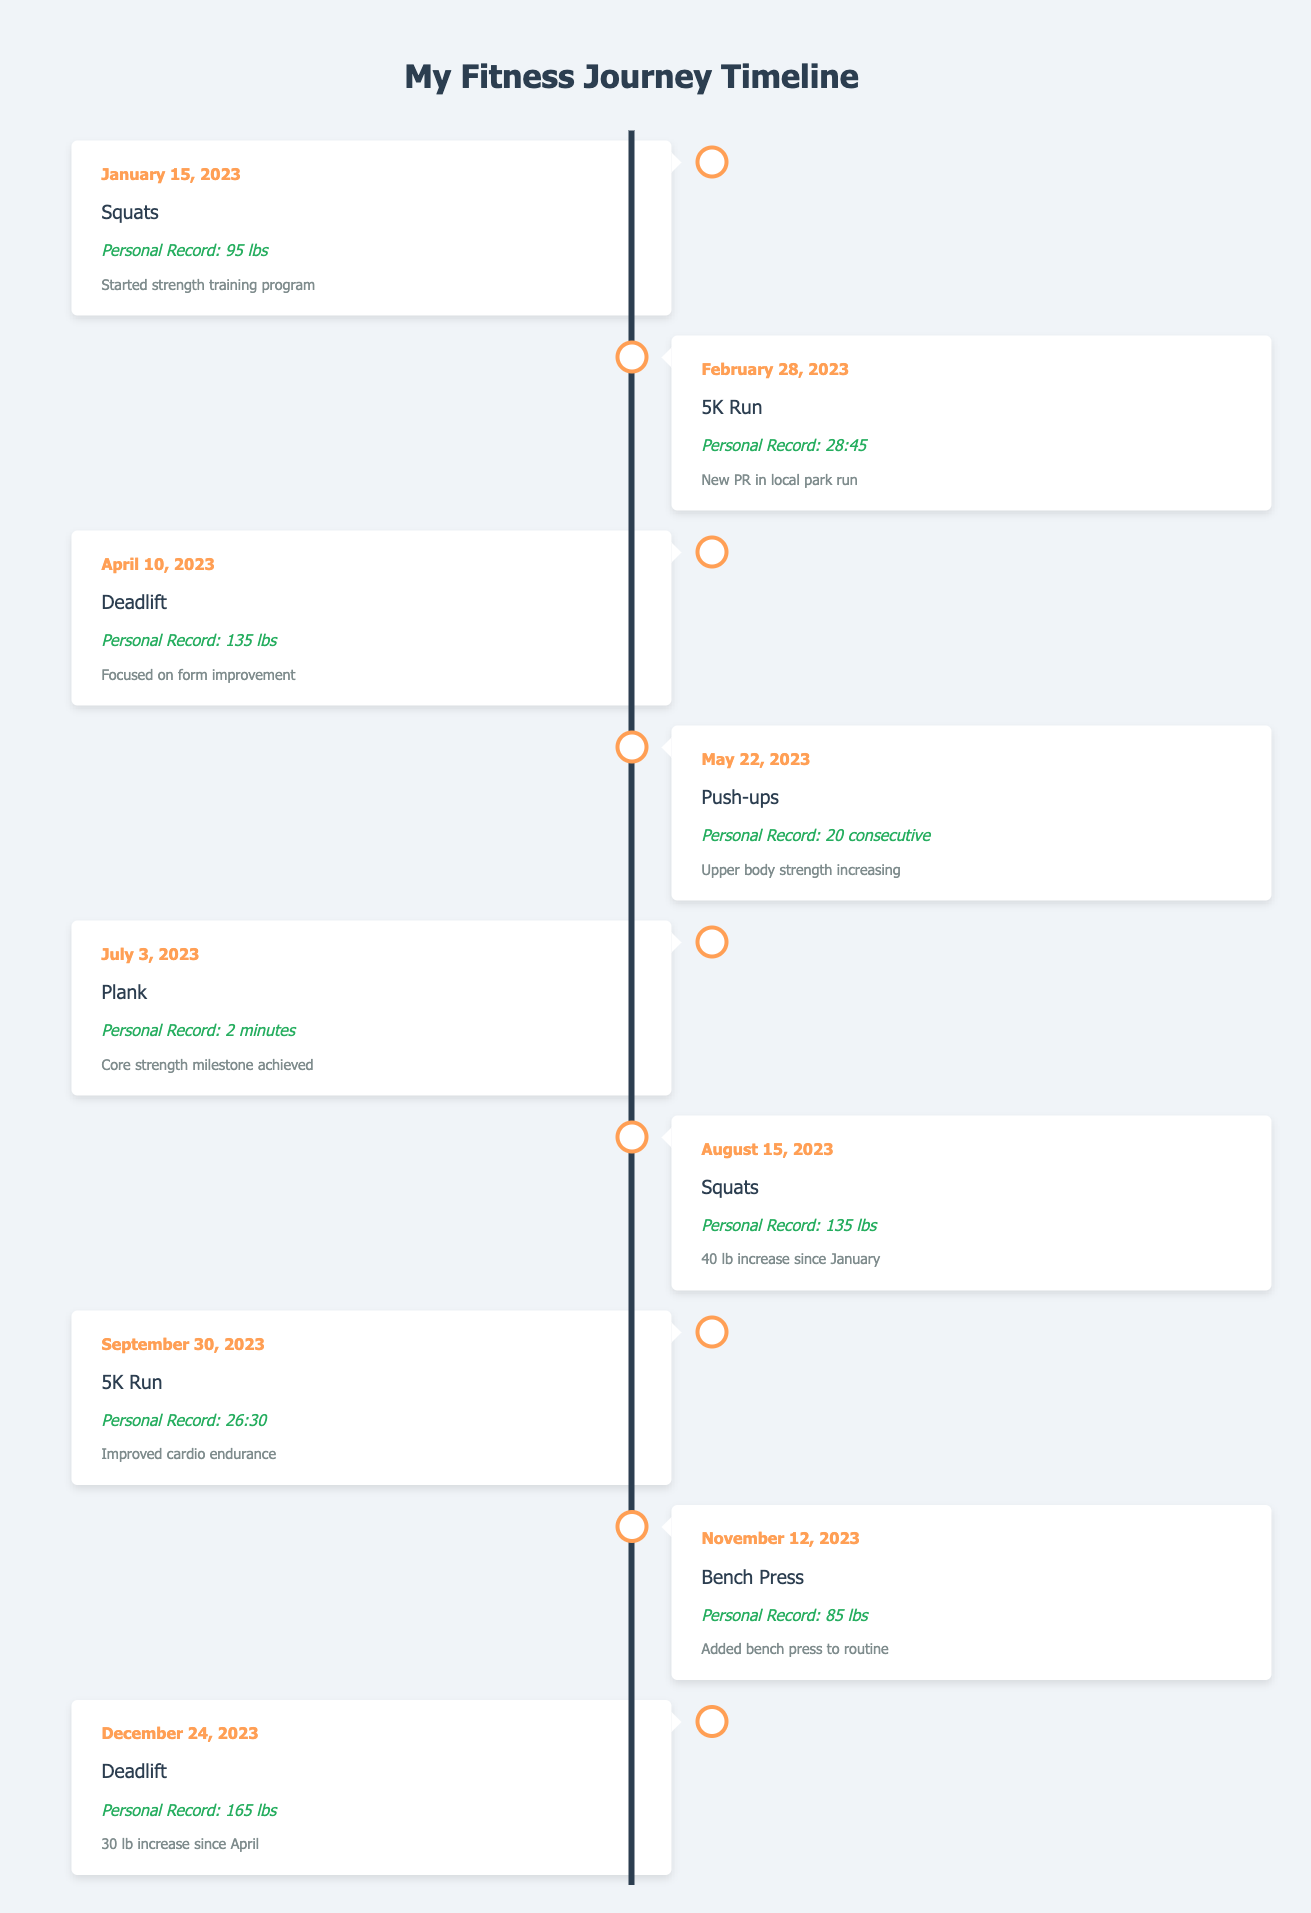What was the personal record for squats on August 15, 2023? On August 15, 2023, the personal record for squats was listed as 135 lbs in the table.
Answer: 135 lbs What is the date associated with the first personal record for deadlifts? The first personal record for deadlifts was recorded on April 10, 2023.
Answer: April 10, 2023 How much did the personal record for squats increase by from January 15, 2023, to August 15, 2023? The personal record for squats increased from 95 lbs in January to 135 lbs in August. To calculate the increase, subtract 95 from 135: 135 - 95 = 40 lbs.
Answer: 40 lbs Is there a personal record for bench press listed earlier than November 12, 2023? No, the first entry for bench press is on November 12, 2023, which means there are no earlier records for that exercise in the table.
Answer: No Which exercise had the highest recorded personal record, and what was that record? The highest recorded personal record was for deadlifts at 165 lbs on December 24, 2023. To find this, we compare the records for all exercises and see that 165 lbs is the highest.
Answer: Deadlifts, 165 lbs Calculate the average personal record time for the 5K runs listed. There are two entries for 5K runs: 28:45 on February 28 and 26:30 on September 30. First, convert the times to seconds: 28:45 = 1725 seconds and 26:30 = 1590 seconds. The average is (1725 + 1590) / 2 = 1657.5 seconds. Converting back to minutes gives approximately 27:37.5.
Answer: 27:37.5 How many exercises had personal records set within the second half of the year? The table lists four exercises with personal records set after June 30, 2023: Plank (July 3), Squats (August 15), 5K Run (September 30), and Bench Press (November 12). Therefore, there are four exercises.
Answer: 4 Did the personal record for the 5K Run improve more than the personal record for any other exercise? Yes, the 5K Run improved from 28:45 to 26:30, a reduction of 2:15. Other exercises had smaller improvements. The largest improvement was 30 lbs in the deadlift, but the time improvement shows a greater performance enhancement in the 5K Run.
Answer: Yes What exercise had a personal record set on July 3, 2023? On July 3, 2023, the exercise recorded was Plank with a personal record of 2 minutes noted in the table.
Answer: Plank 